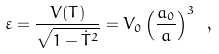<formula> <loc_0><loc_0><loc_500><loc_500>\varepsilon = { \frac { V ( T ) } { \sqrt { 1 - \dot { T } ^ { 2 } } } } = V _ { 0 } \left ( { \frac { a _ { 0 } } { a } } \right ) ^ { 3 } \ ,</formula> 